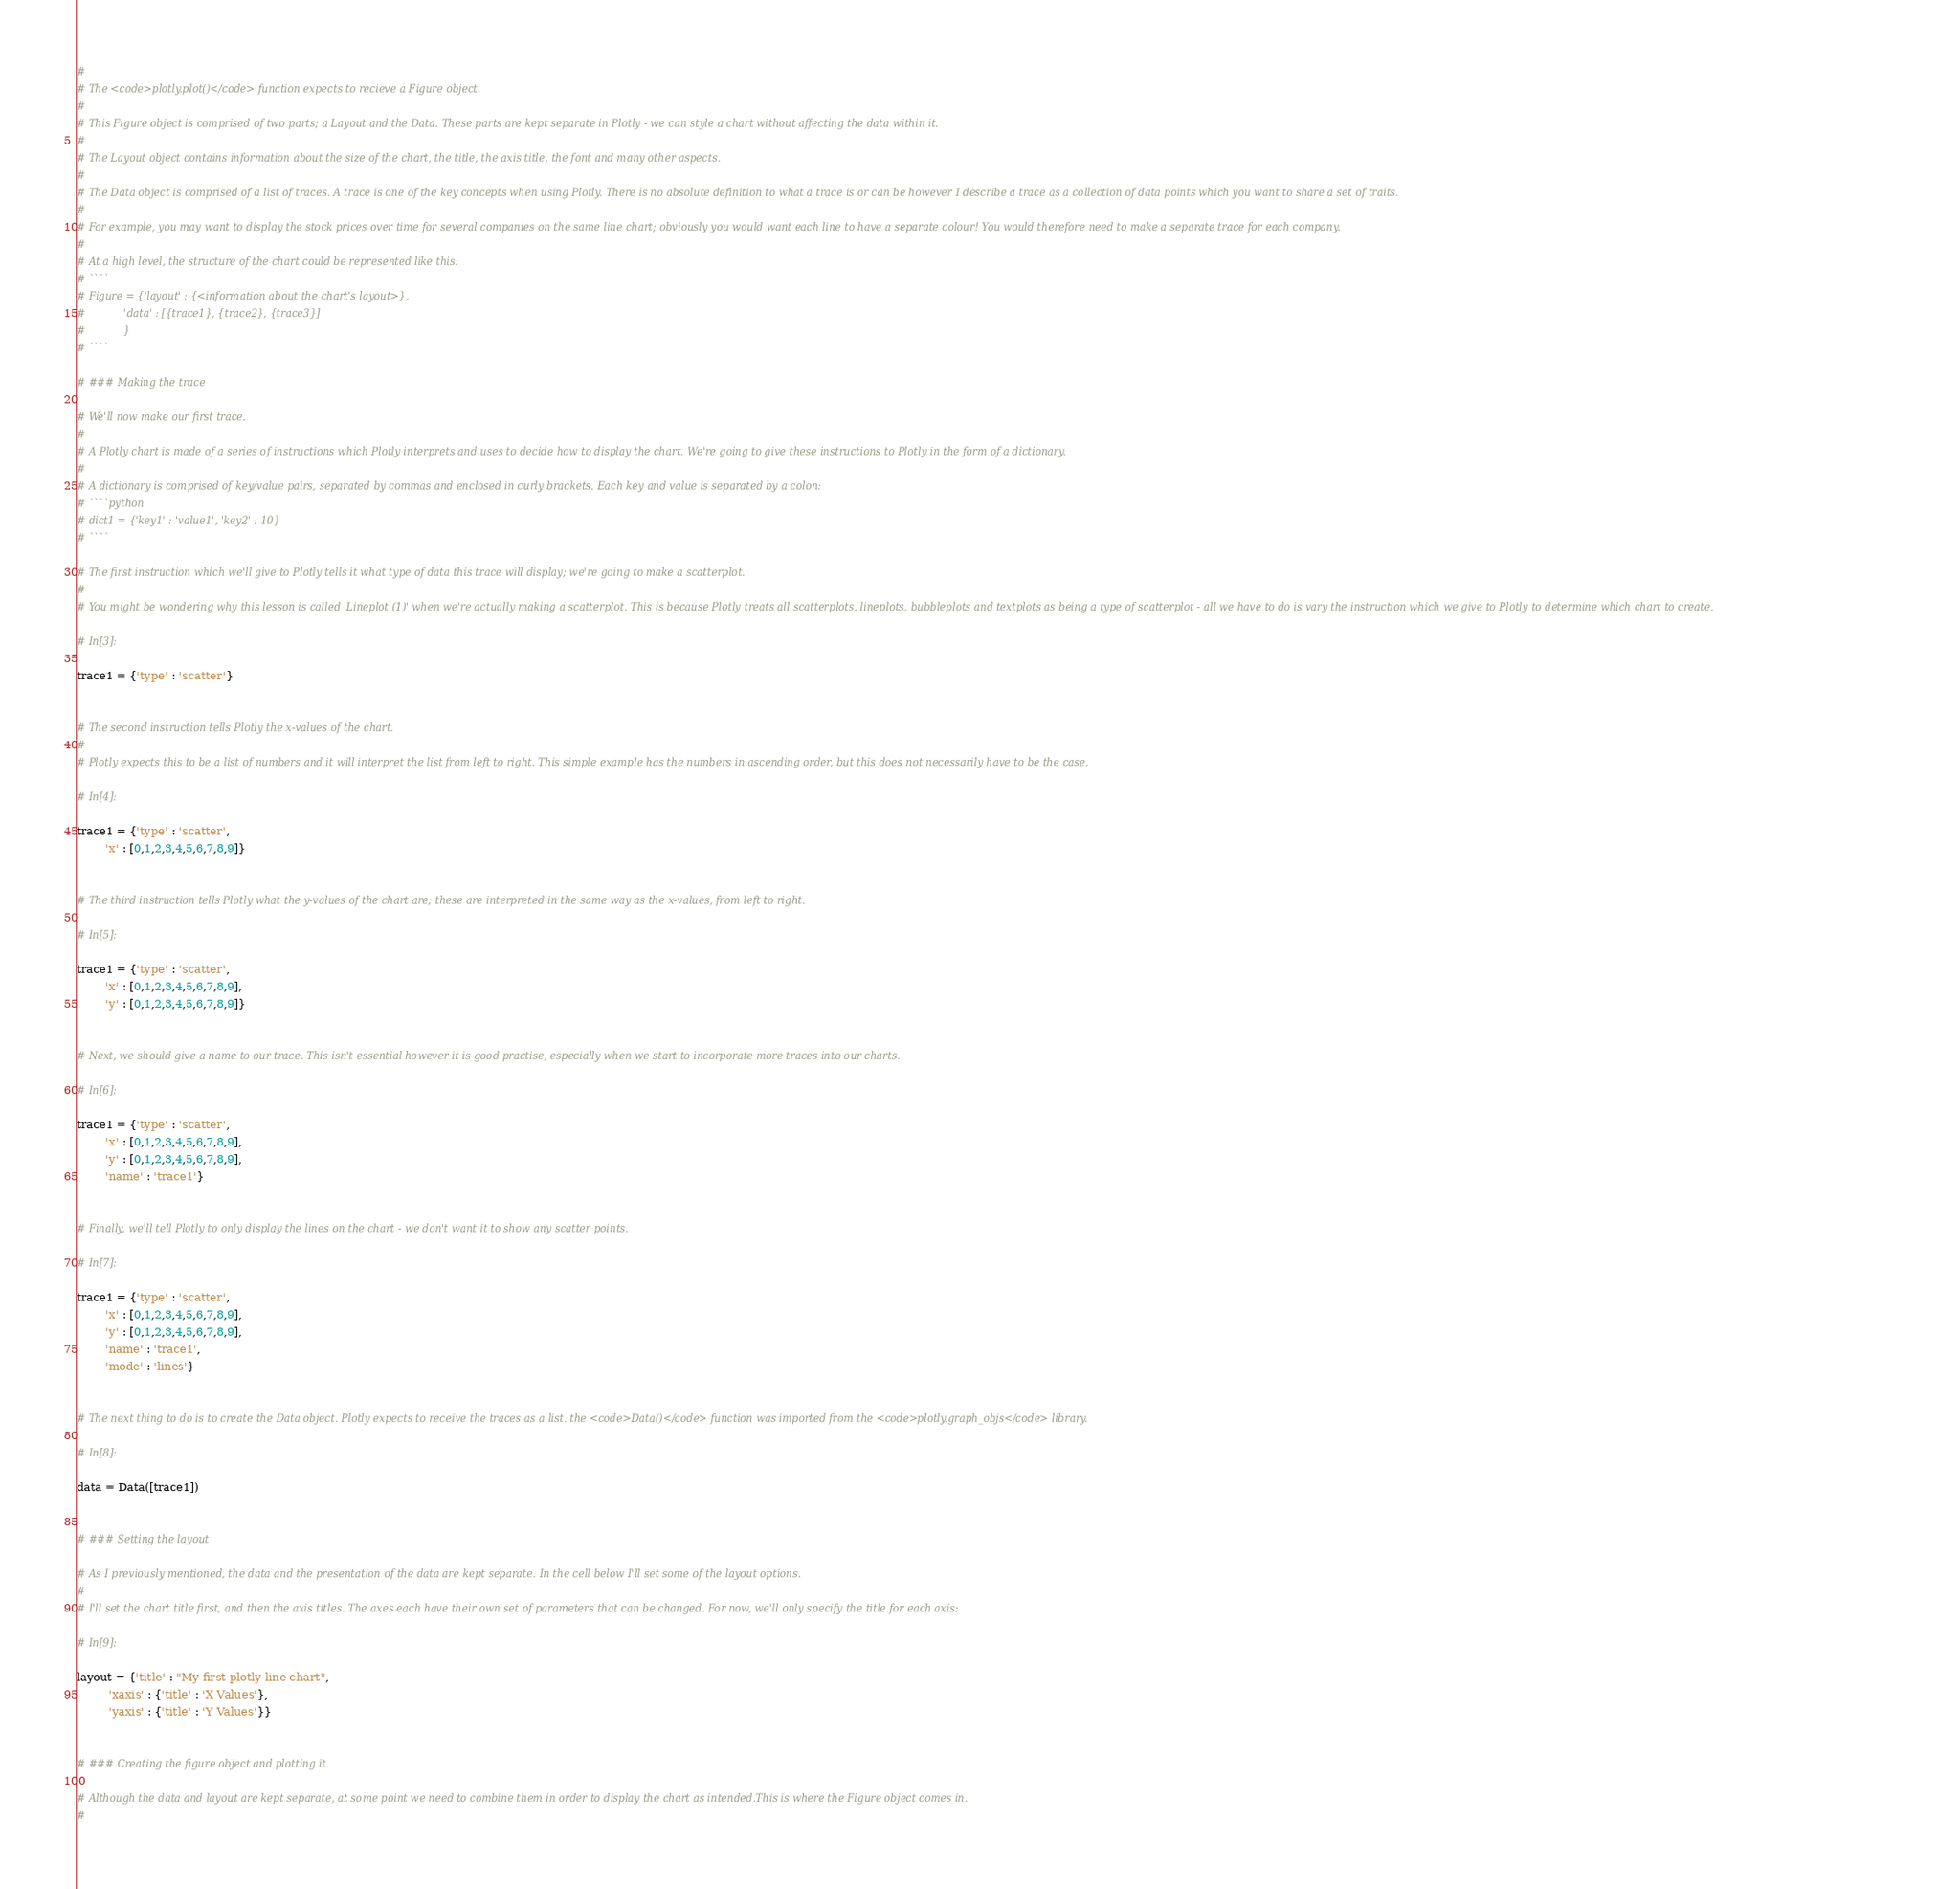Convert code to text. <code><loc_0><loc_0><loc_500><loc_500><_Python_># 
# The <code>plotly.plot()</code> function expects to recieve a Figure object.
# 
# This Figure object is comprised of two parts; a Layout and the Data. These parts are kept separate in Plotly - we can style a chart without affecting the data within it.
# 
# The Layout object contains information about the size of the chart, the title, the axis title, the font and many other aspects.
# 
# The Data object is comprised of a list of traces. A trace is one of the key concepts when using Plotly. There is no absolute definition to what a trace is or can be however I describe a trace as a collection of data points which you want to share a set of traits. 
# 
# For example, you may want to display the stock prices over time for several companies on the same line chart; obviously you would want each line to have a separate colour! You would therefore need to make a separate trace for each company.
# 
# At a high level, the structure of the chart could be represented like this:
# ````
# Figure = {'layout' : {<information about the chart's layout>},
#            'data' : [{trace1}, {trace2}, {trace3}]
#            }
# ````

# ### Making the trace

# We'll now make our first trace.
# 
# A Plotly chart is made of a series of instructions which Plotly interprets and uses to decide how to display the chart. We're going to give these instructions to Plotly in the form of a dictionary.
# 
# A dictionary is comprised of key/value pairs, separated by commas and enclosed in curly brackets. Each key and value is separated by a colon:
# ````python
# dict1 = {'key1' : 'value1', 'key2' : 10}
# ````

# The first instruction which we'll give to Plotly tells it what type of data this trace will display; we're going to make a scatterplot. 
# 
# You might be wondering why this lesson is called 'Lineplot (1)' when we're actually making a scatterplot. This is because Plotly treats all scatterplots, lineplots, bubbleplots and textplots as being a type of scatterplot - all we have to do is vary the instruction which we give to Plotly to determine which chart to create.

# In[3]:

trace1 = {'type' : 'scatter'}


# The second instruction tells Plotly the x-values of the chart.
# 
# Plotly expects this to be a list of numbers and it will interpret the list from left to right. This simple example has the numbers in ascending order, but this does not necessarily have to be the case.

# In[4]:

trace1 = {'type' : 'scatter',
        'x' : [0,1,2,3,4,5,6,7,8,9]}


# The third instruction tells Plotly what the y-values of the chart are; these are interpreted in the same way as the x-values, from left to right.

# In[5]:

trace1 = {'type' : 'scatter',
        'x' : [0,1,2,3,4,5,6,7,8,9],
        'y' : [0,1,2,3,4,5,6,7,8,9]}


# Next, we should give a name to our trace. This isn't essential however it is good practise, especially when we start to incorporate more traces into our charts.

# In[6]:

trace1 = {'type' : 'scatter',
        'x' : [0,1,2,3,4,5,6,7,8,9],
        'y' : [0,1,2,3,4,5,6,7,8,9],
        'name' : 'trace1'}


# Finally, we'll tell Plotly to only display the lines on the chart - we don't want it to show any scatter points.

# In[7]:

trace1 = {'type' : 'scatter',
        'x' : [0,1,2,3,4,5,6,7,8,9],
        'y' : [0,1,2,3,4,5,6,7,8,9],
        'name' : 'trace1',
        'mode' : 'lines'}


# The next thing to do is to create the Data object. Plotly expects to receive the traces as a list. the <code>Data()</code> function was imported from the <code>plotly.graph_objs</code> library.

# In[8]:

data = Data([trace1])


# ### Setting the layout

# As I previously mentioned, the data and the presentation of the data are kept separate. In the cell below I'll set some of the layout options.
# 
# I'll set the chart title first, and then the axis titles. The axes each have their own set of parameters that can be changed. For now, we'll only specify the title for each axis:

# In[9]:

layout = {'title' : "My first plotly line chart",
         'xaxis' : {'title' : 'X Values'},
         'yaxis' : {'title' : 'Y Values'}}


# ### Creating the figure object and plotting it

# Although the data and layout are kept separate, at some point we need to combine them in order to display the chart as intended.This is where the Figure object comes in. 
# </code> 